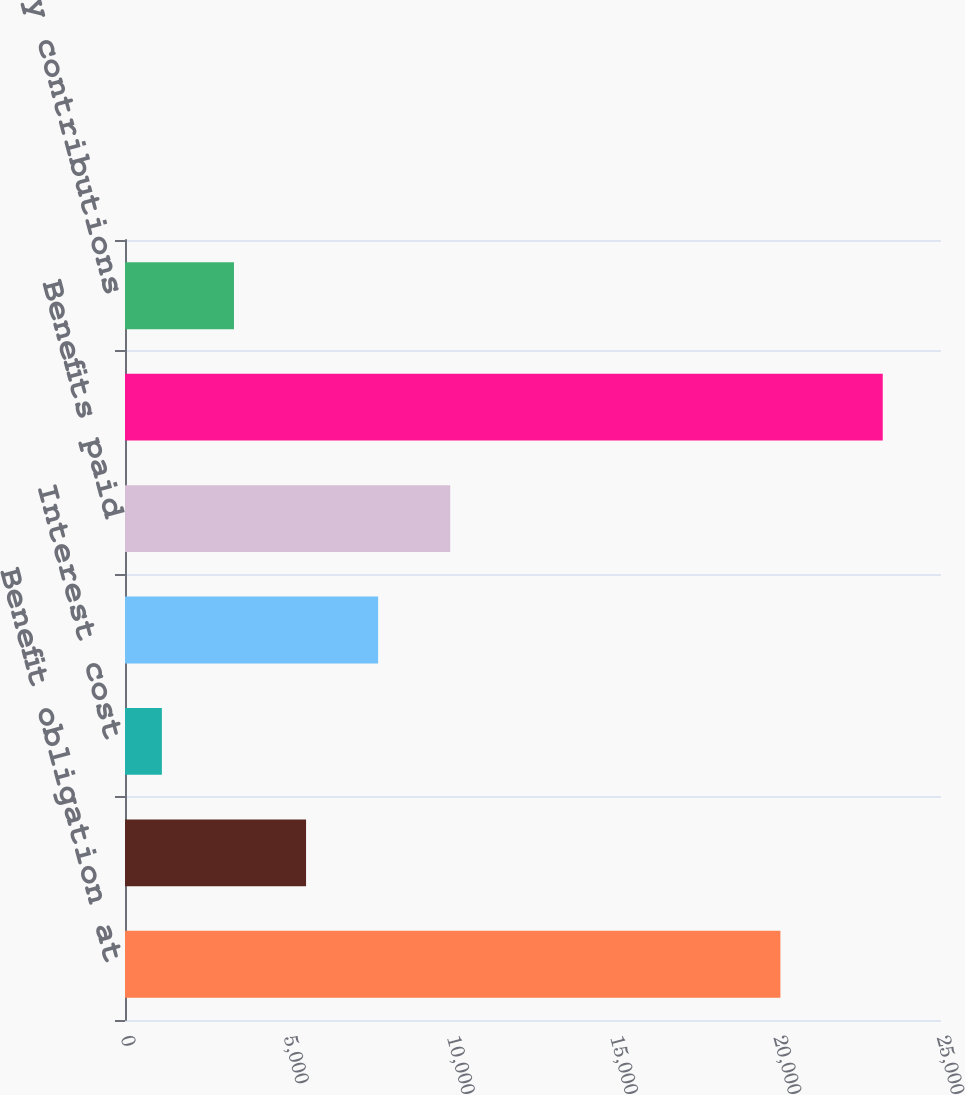Convert chart to OTSL. <chart><loc_0><loc_0><loc_500><loc_500><bar_chart><fcel>Benefit obligation at<fcel>Service cost<fcel>Interest cost<fcel>Actuarial loss<fcel>Benefits paid<fcel>Benefit obligation at plan<fcel>Company contributions<nl><fcel>20080<fcel>5547<fcel>1130<fcel>7755.5<fcel>9964<fcel>23215<fcel>3338.5<nl></chart> 